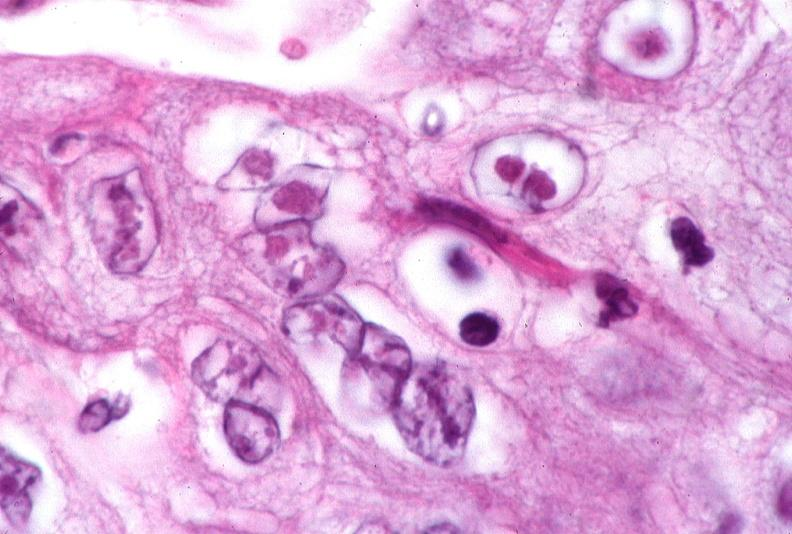does ameloblastoma show skin, herpes inclusions?
Answer the question using a single word or phrase. No 